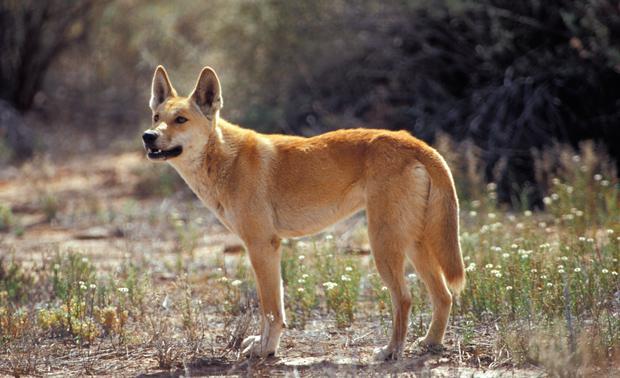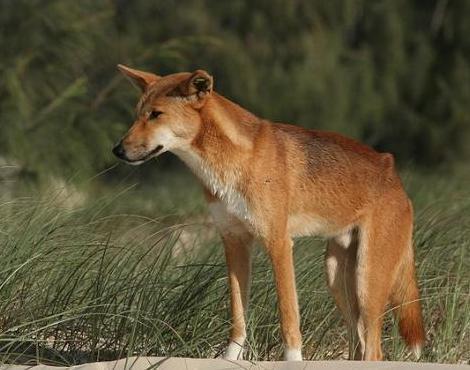The first image is the image on the left, the second image is the image on the right. Assess this claim about the two images: "there are two animals". Correct or not? Answer yes or no. Yes. 